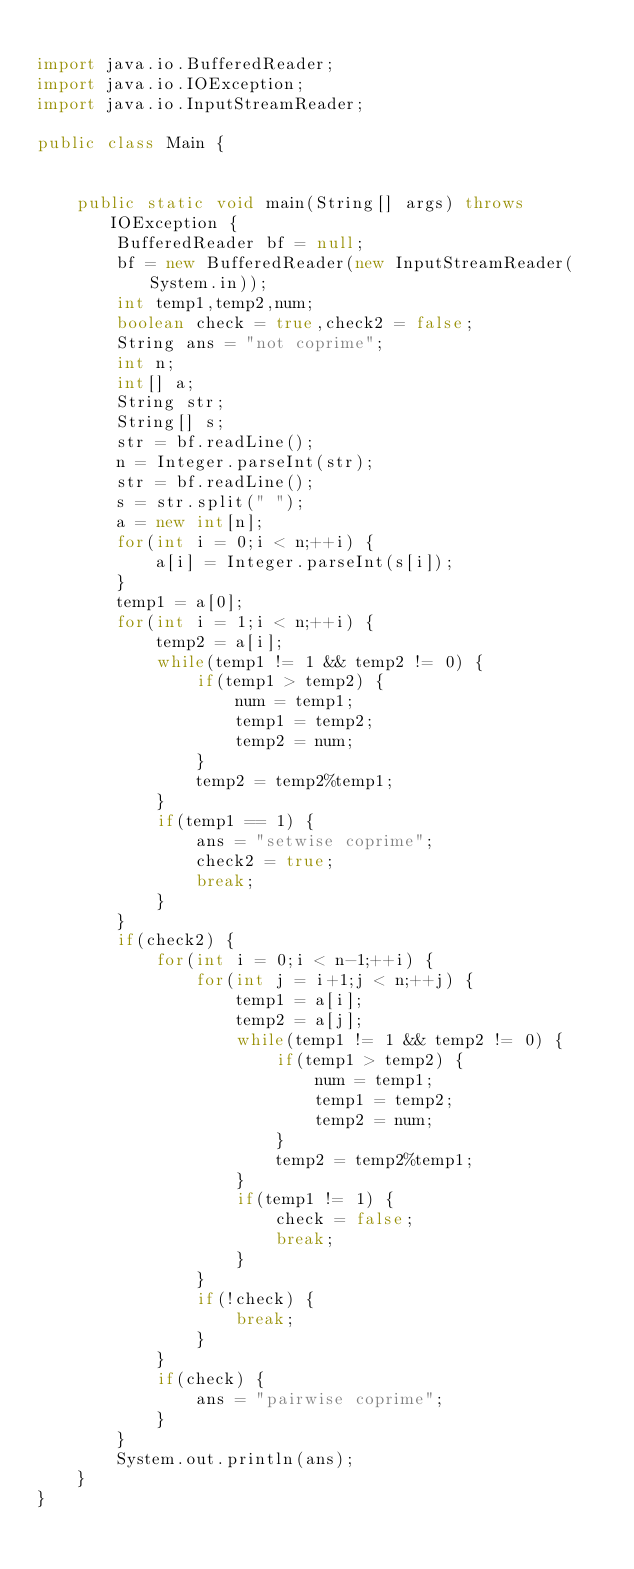<code> <loc_0><loc_0><loc_500><loc_500><_Java_>
import java.io.BufferedReader;
import java.io.IOException;
import java.io.InputStreamReader;

public class Main {


	public static void main(String[] args) throws IOException {
		BufferedReader bf = null;
		bf = new BufferedReader(new InputStreamReader(System.in));
		int temp1,temp2,num;
		boolean check = true,check2 = false;
		String ans = "not coprime";
		int n;
		int[] a;
		String str;
		String[] s;
		str = bf.readLine();
		n = Integer.parseInt(str);
		str = bf.readLine();
		s = str.split(" ");
		a = new int[n];
		for(int i = 0;i < n;++i) {
			a[i] = Integer.parseInt(s[i]);
		}
		temp1 = a[0];
		for(int i = 1;i < n;++i) {
			temp2 = a[i];
			while(temp1 != 1 && temp2 != 0) {
				if(temp1 > temp2) {
					num = temp1;
					temp1 = temp2;
					temp2 = num;
				}
				temp2 = temp2%temp1;
			}
			if(temp1 == 1) {
				ans = "setwise coprime";
				check2 = true;
				break;
			}
		}
		if(check2) {
			for(int i = 0;i < n-1;++i) {
				for(int j = i+1;j < n;++j) {
					temp1 = a[i];
					temp2 = a[j];
					while(temp1 != 1 && temp2 != 0) {
						if(temp1 > temp2) {
							num = temp1;
							temp1 = temp2;
							temp2 = num;
						}
						temp2 = temp2%temp1;
					}
					if(temp1 != 1) {
						check = false;
						break;
					}
				}
				if(!check) {
					break;
				}
			}
			if(check) {
				ans = "pairwise coprime";
			}
		}
		System.out.println(ans);
	}
}</code> 